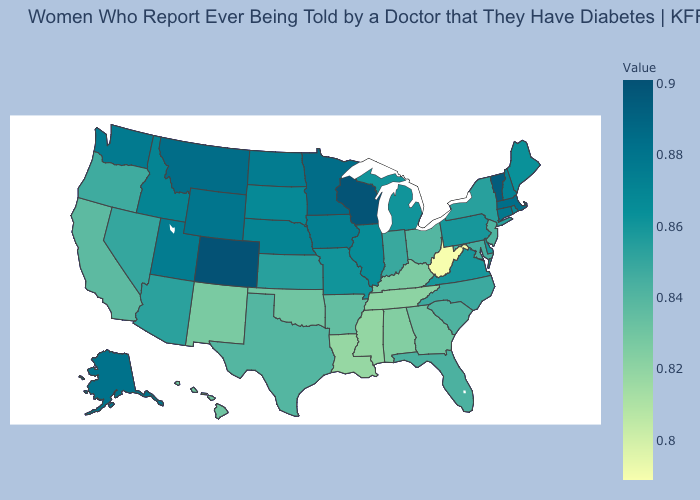Among the states that border New Hampshire , does Massachusetts have the highest value?
Write a very short answer. No. Is the legend a continuous bar?
Give a very brief answer. Yes. Does Wyoming have a lower value than Colorado?
Quick response, please. Yes. Which states have the lowest value in the Northeast?
Concise answer only. New Jersey. Which states have the lowest value in the West?
Keep it brief. New Mexico. Is the legend a continuous bar?
Give a very brief answer. Yes. Which states have the lowest value in the USA?
Concise answer only. West Virginia. Which states have the lowest value in the South?
Give a very brief answer. West Virginia. Among the states that border Utah , which have the highest value?
Short answer required. Colorado. 